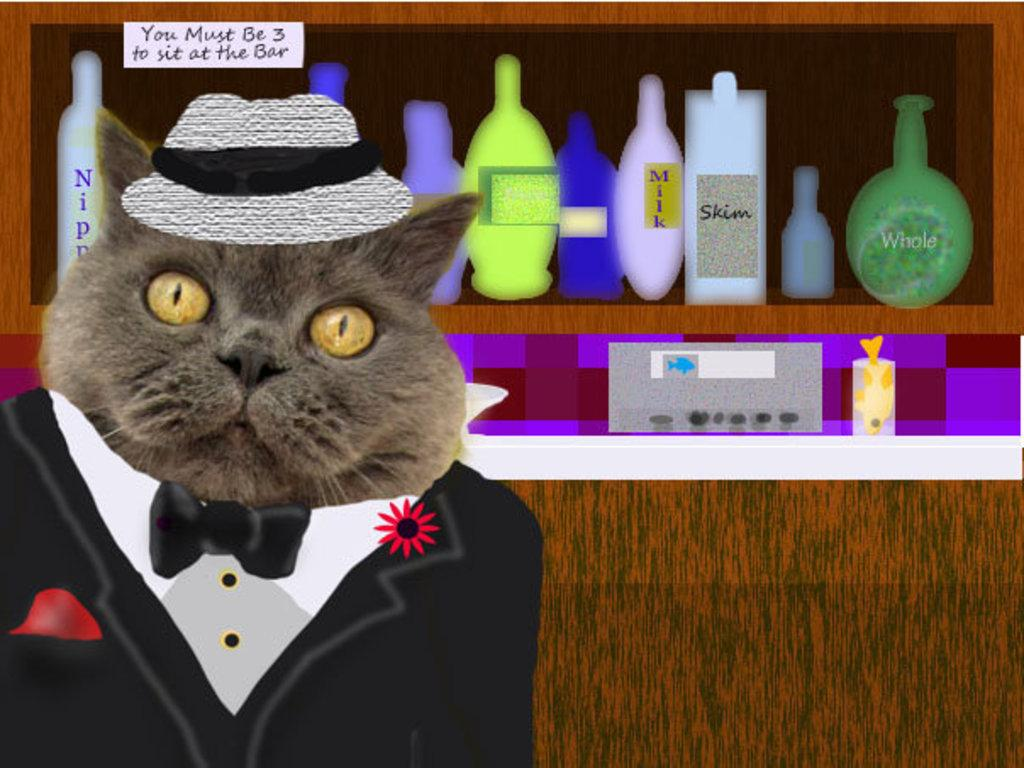What type of image is in the picture? There is a cartoon image in the picture. What animal is featured in the cartoon image? The cartoon image features a cat. What accessories is the cat wearing? The cat is wearing a cap and a suit. What can be seen in the background of the image? There are bottles arranged on a shelf in the background of the image. What type of loaf is the cat holding in the image? There is no loaf present in the image; the cat is not holding anything. Can you tell me how the cat's bone is positioned in the image? There is no bone present in the image; the cat is not interacting with any bones. 